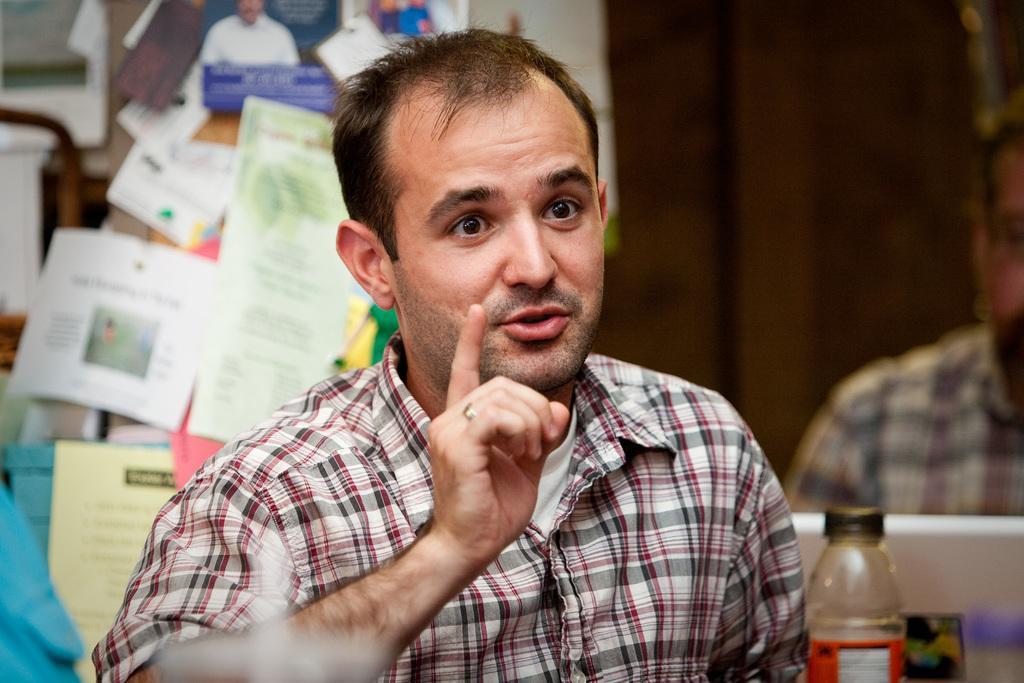How would you summarize this image in a sentence or two? In this image I can see two people. In the back there are some papers to the wall. 